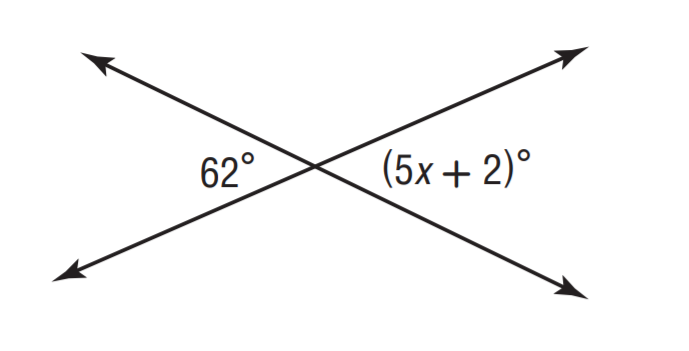Answer the mathemtical geometry problem and directly provide the correct option letter.
Question: Solve for x.
Choices: A: 9 B: 10 C: 11 D: 12 D 